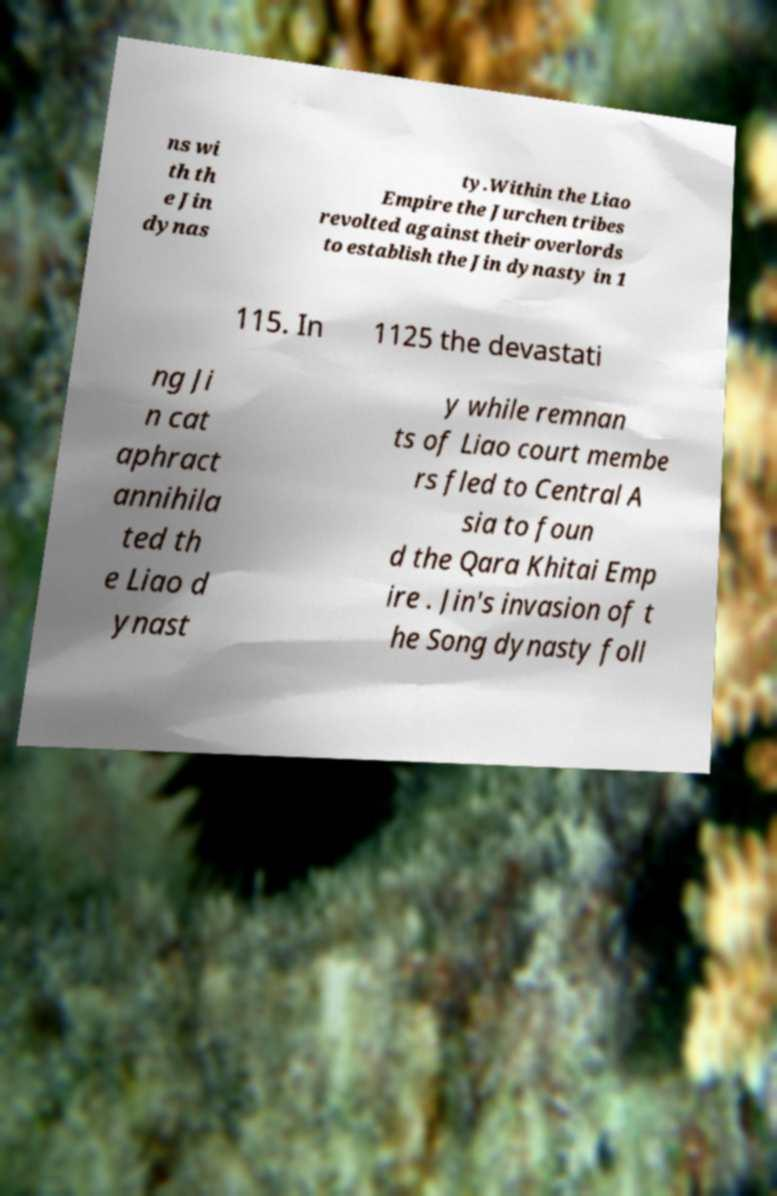There's text embedded in this image that I need extracted. Can you transcribe it verbatim? ns wi th th e Jin dynas ty.Within the Liao Empire the Jurchen tribes revolted against their overlords to establish the Jin dynasty in 1 115. In 1125 the devastati ng Ji n cat aphract annihila ted th e Liao d ynast y while remnan ts of Liao court membe rs fled to Central A sia to foun d the Qara Khitai Emp ire . Jin's invasion of t he Song dynasty foll 